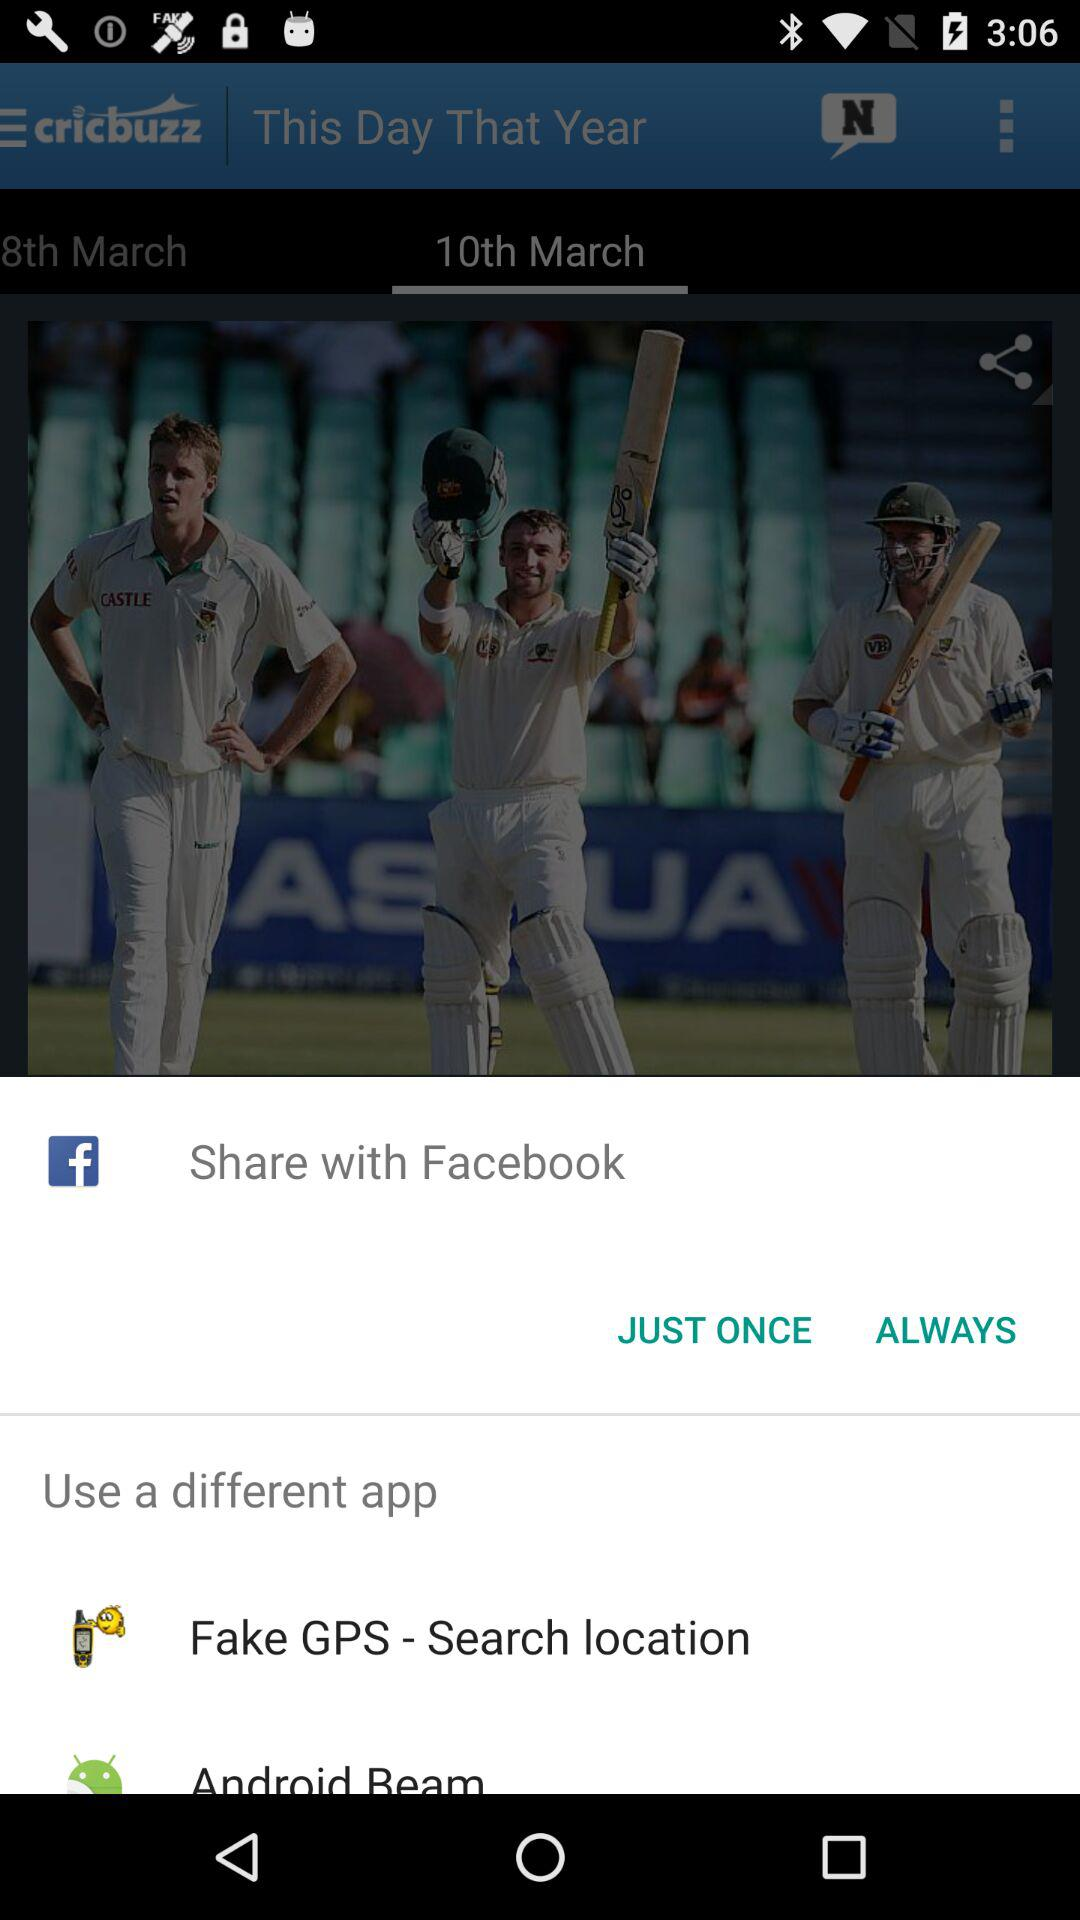What year is "That Year"?
When the provided information is insufficient, respond with <no answer>. <no answer> 